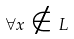Convert formula to latex. <formula><loc_0><loc_0><loc_500><loc_500>\forall x \notin L</formula> 